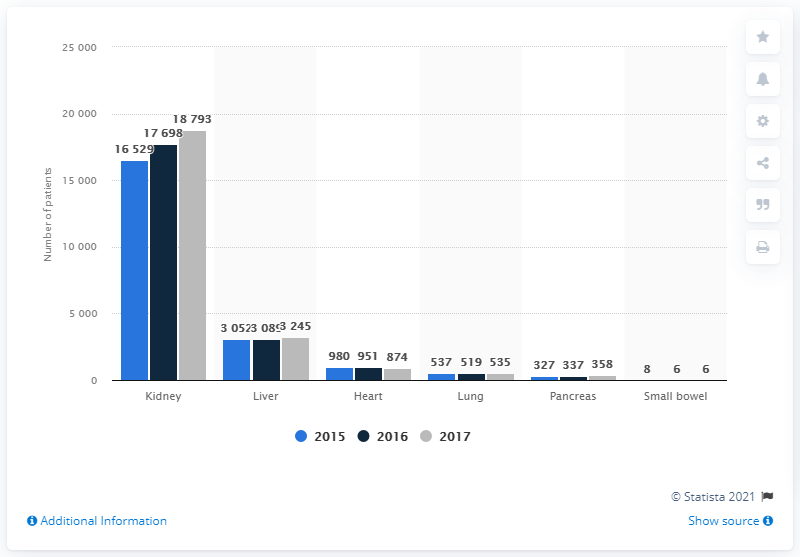Draw attention to some important aspects in this diagram. In 2017, there were 18,793 patients on the waiting list for a kidney transplant. 